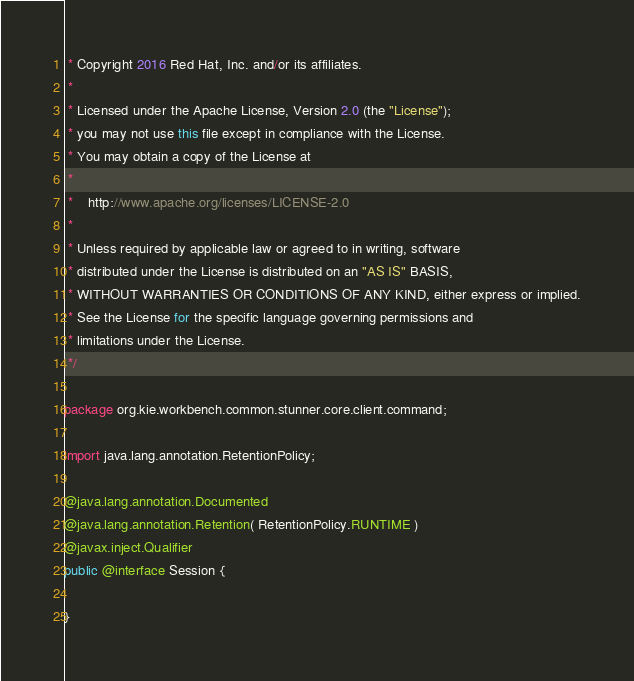Convert code to text. <code><loc_0><loc_0><loc_500><loc_500><_Java_> * Copyright 2016 Red Hat, Inc. and/or its affiliates.
 *
 * Licensed under the Apache License, Version 2.0 (the "License");
 * you may not use this file except in compliance with the License.
 * You may obtain a copy of the License at
 *
 * 	http://www.apache.org/licenses/LICENSE-2.0
 *
 * Unless required by applicable law or agreed to in writing, software
 * distributed under the License is distributed on an "AS IS" BASIS,
 * WITHOUT WARRANTIES OR CONDITIONS OF ANY KIND, either express or implied.
 * See the License for the specific language governing permissions and
 * limitations under the License.
 */

package org.kie.workbench.common.stunner.core.client.command;

import java.lang.annotation.RetentionPolicy;

@java.lang.annotation.Documented
@java.lang.annotation.Retention( RetentionPolicy.RUNTIME )
@javax.inject.Qualifier
public @interface Session {

}</code> 